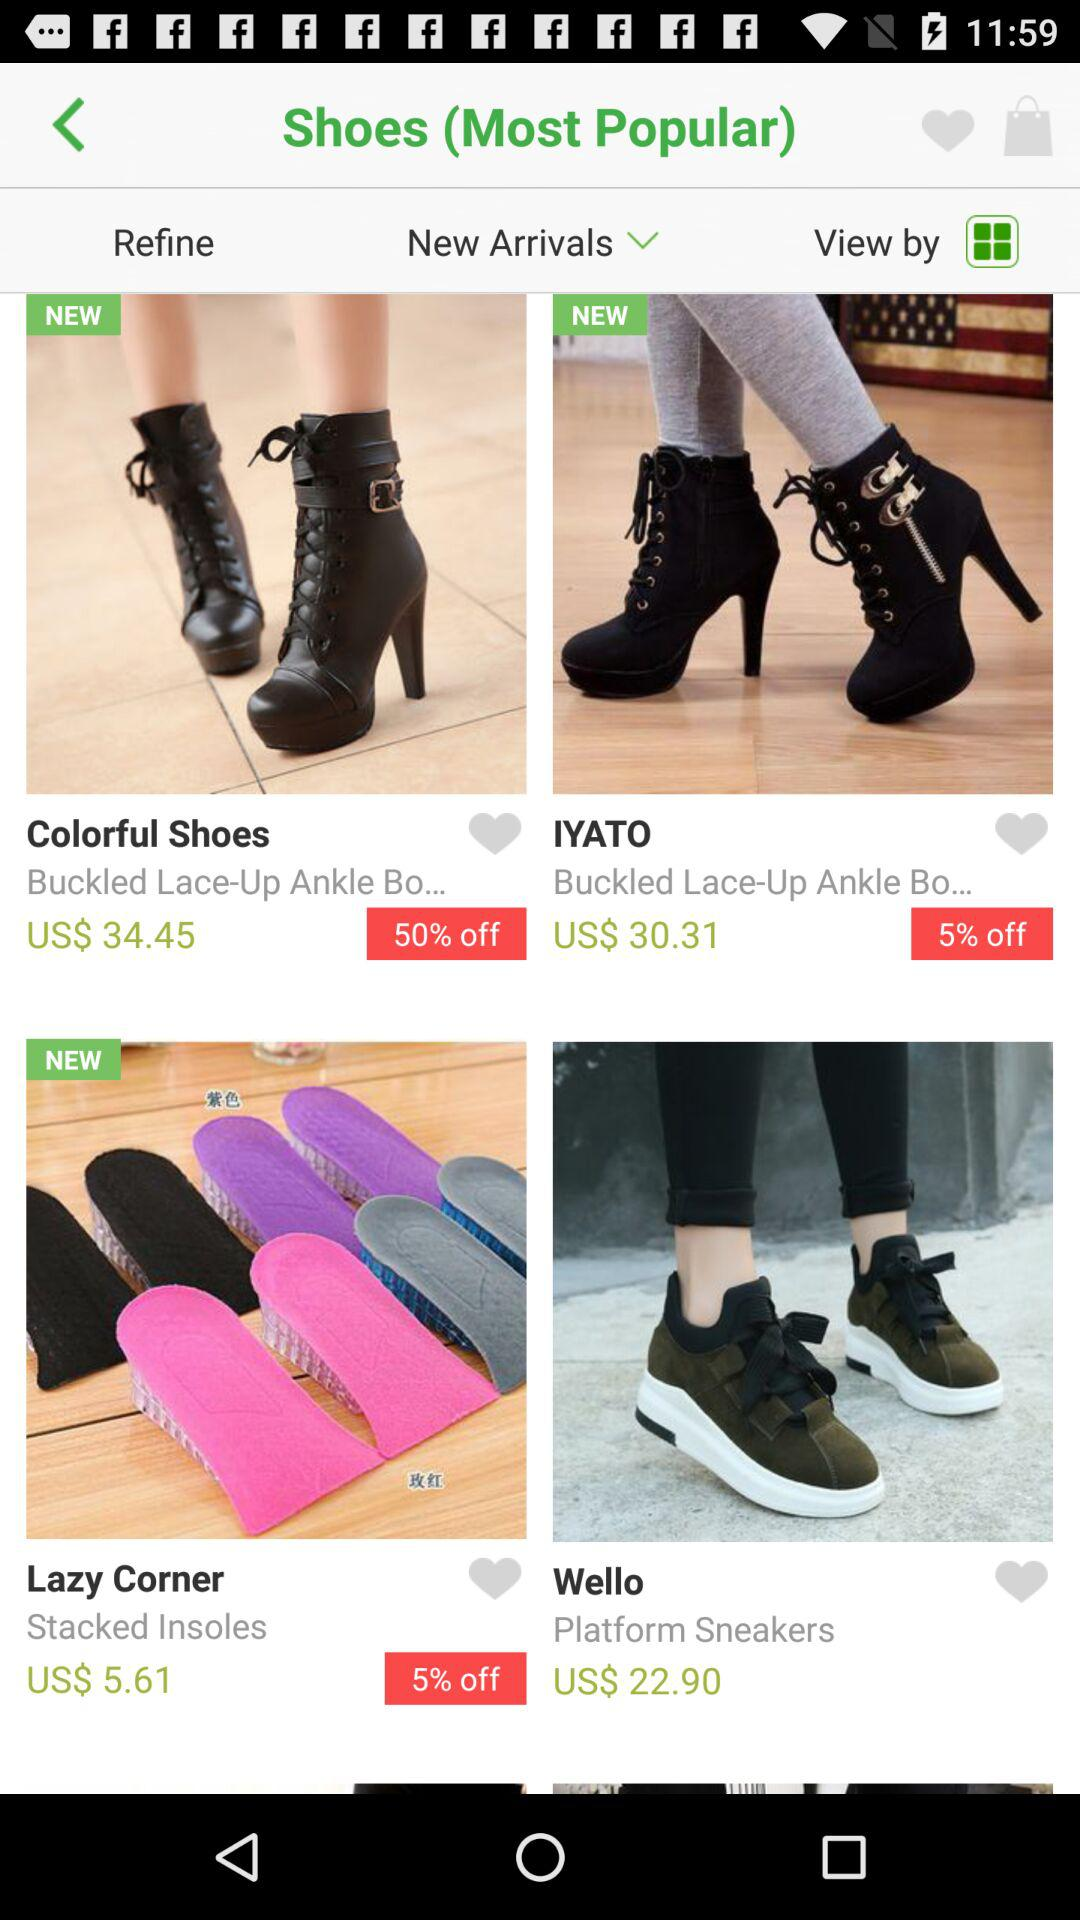What is the price for the "Colorful Shoes"? The price for the "Colorful Shoes" is 34.45 USD. 